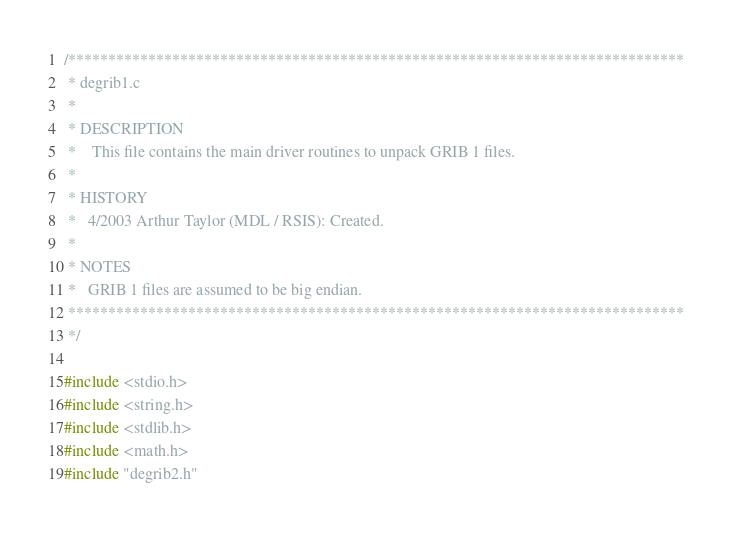Convert code to text. <code><loc_0><loc_0><loc_500><loc_500><_C++_>/*****************************************************************************
 * degrib1.c
 *
 * DESCRIPTION
 *    This file contains the main driver routines to unpack GRIB 1 files.
 *
 * HISTORY
 *   4/2003 Arthur Taylor (MDL / RSIS): Created.
 *
 * NOTES
 *   GRIB 1 files are assumed to be big endian.
 *****************************************************************************
 */

#include <stdio.h>
#include <string.h>
#include <stdlib.h>
#include <math.h>
#include "degrib2.h"</code> 